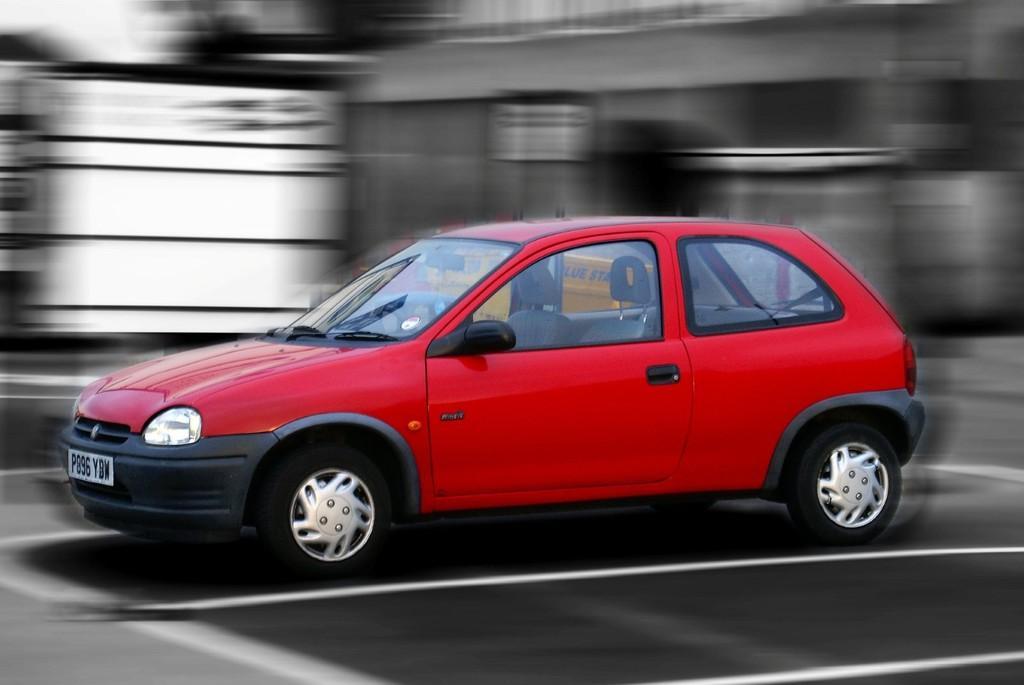Could you give a brief overview of what you see in this image? In this image we can see a red color car on the road, and the background is blurred. 